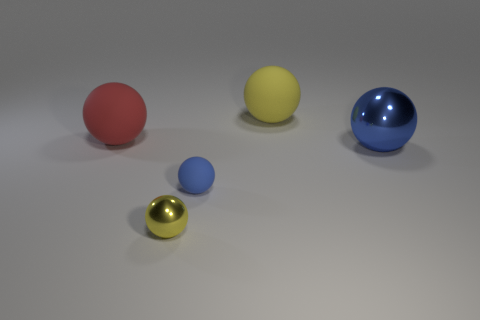Subtract all red spheres. How many spheres are left? 4 Subtract all big red matte spheres. How many spheres are left? 4 Subtract all purple balls. Subtract all cyan blocks. How many balls are left? 5 Add 4 large yellow rubber things. How many objects exist? 9 Add 3 large yellow things. How many large yellow things are left? 4 Add 3 big rubber spheres. How many big rubber spheres exist? 5 Subtract 0 purple spheres. How many objects are left? 5 Subtract all blue shiny spheres. Subtract all big brown matte spheres. How many objects are left? 4 